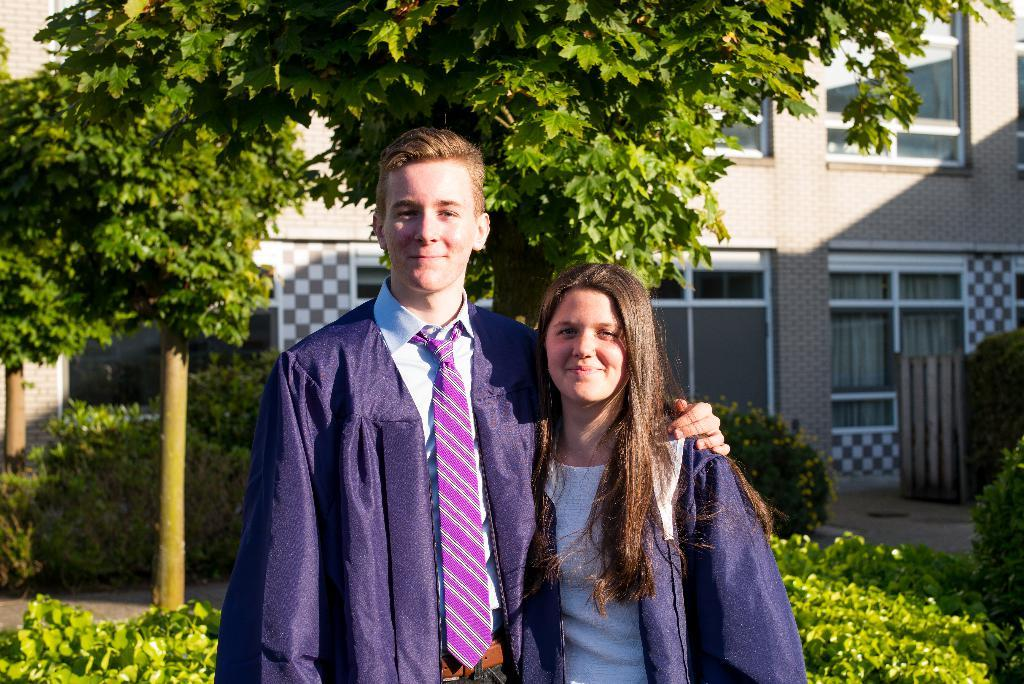How many people are in the image? There are two persons in the image. What are the persons doing in the image? The persons are standing and smiling. What can be seen in the background of the image? There are trees, plants, and a building in the background of the image. What type of pies are being exchanged between the persons in the image? There are no pies present in the image, nor is there any exchange taking place between the persons. What type of alley can be seen in the background of the image? There is no alley visible in the background of the image; it features trees, plants, and a building. 